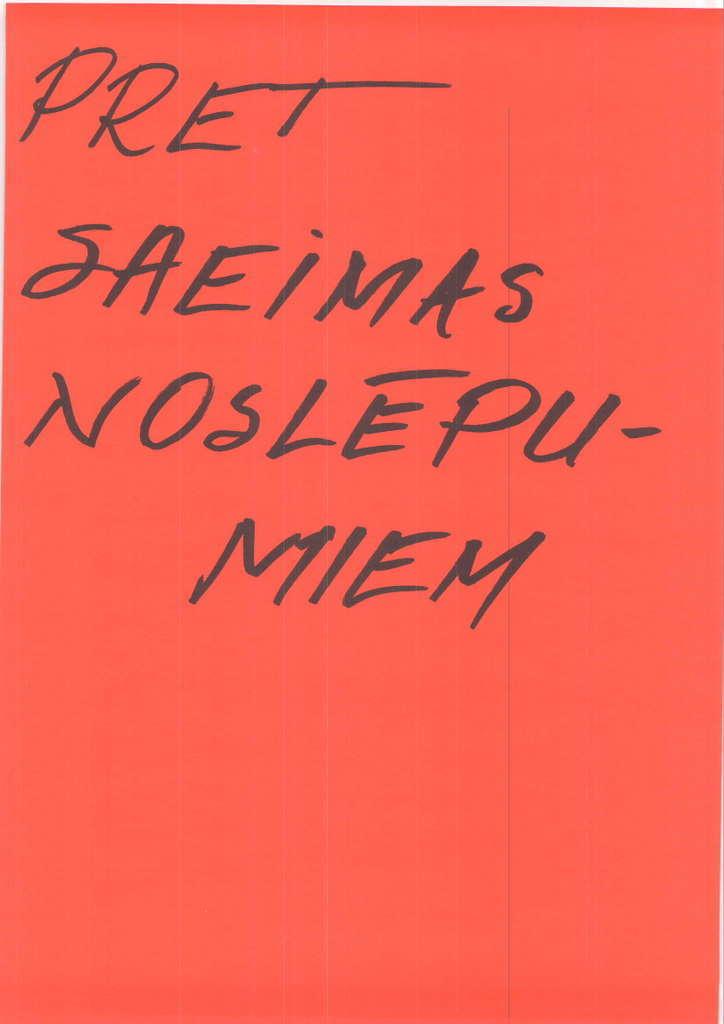What are the letters of the first line?
Give a very brief answer. Pret. 